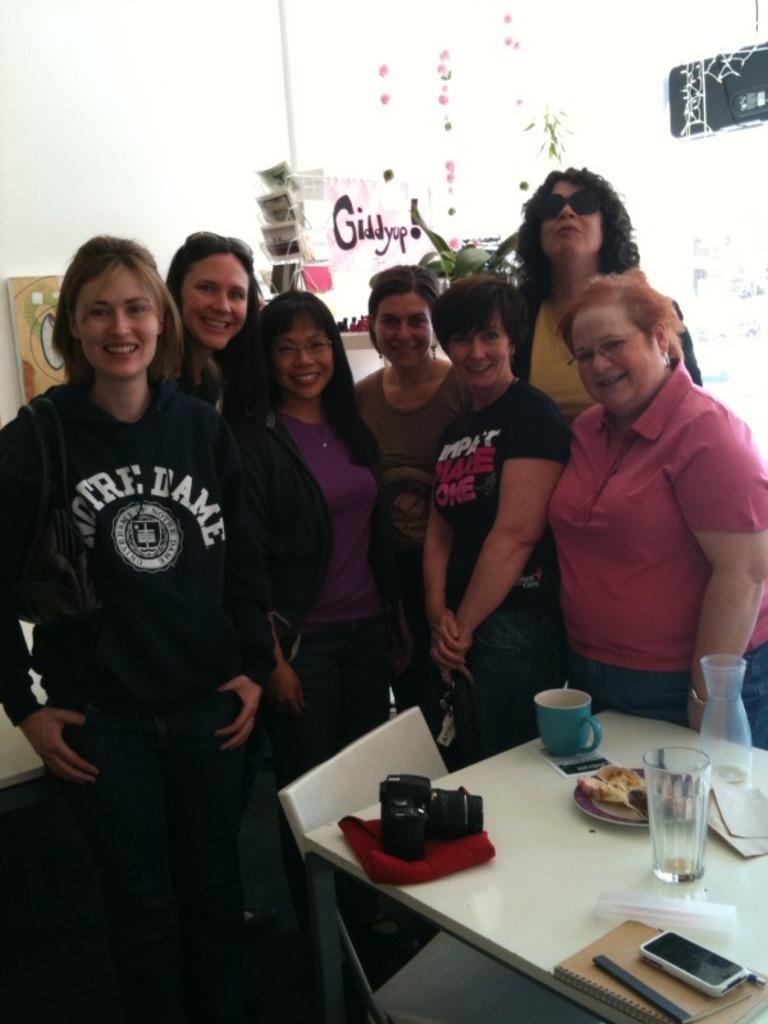In one or two sentences, can you explain what this image depicts? In the picture there are seven women standing, all of them are laughing , there is a white color table in front of them ,there is a cup, some food ,a glass, a mobile , book, a camera and tissues on the table , there is a chair beside the table. In the background ,there are some crafts and a white color wall. 